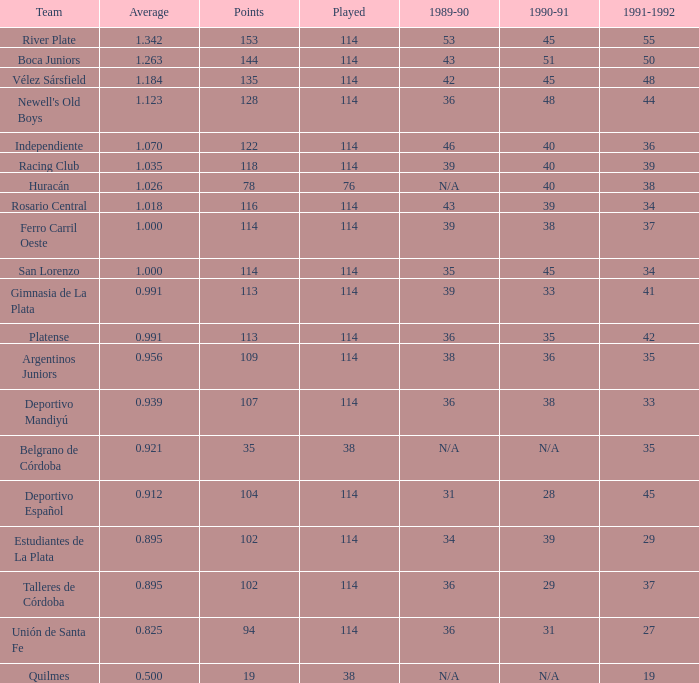How much does the 1991-1992 team of gimnasia de la plata possess, with over 113 points? 0.0. 